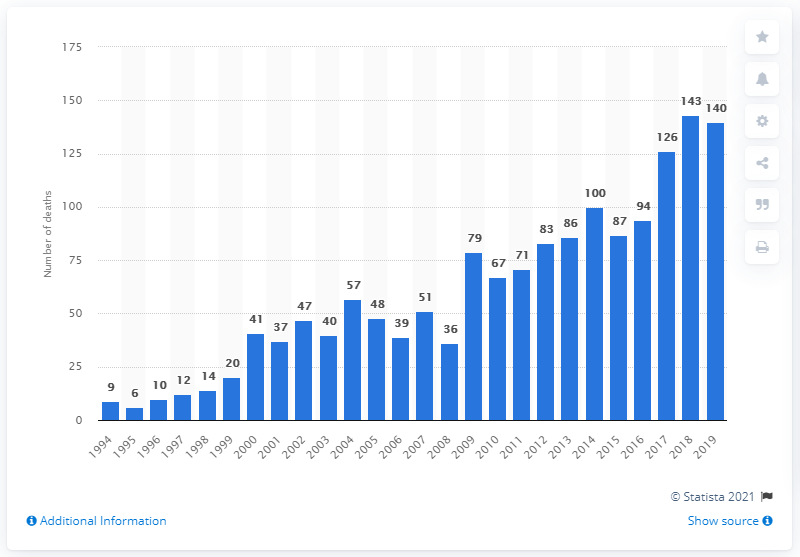Point out several critical features in this image. In 2019, there were 140 reported deaths related to the combined use of zopiclone and zolpidem. 